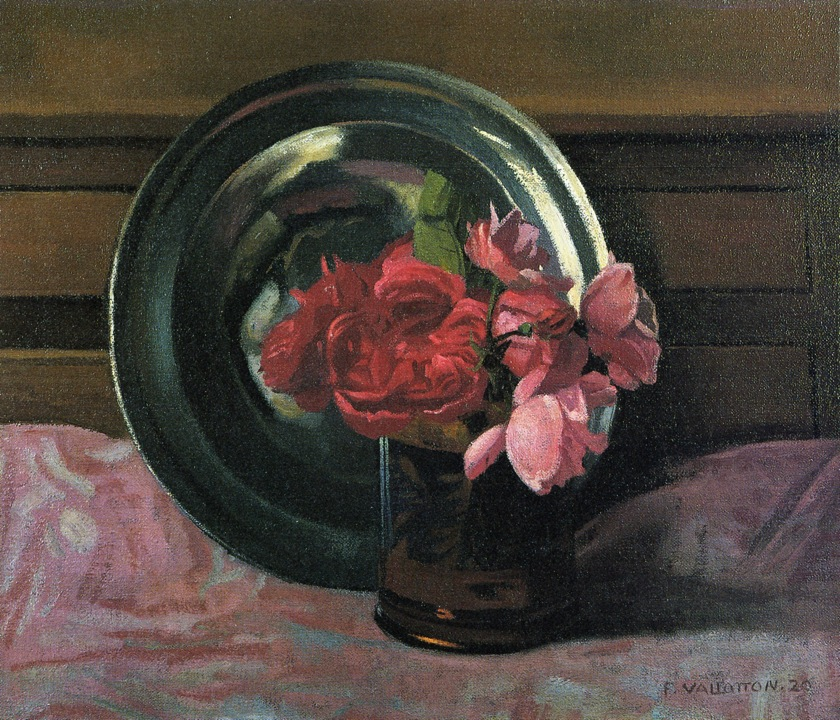Imagine this painting as part of a larger narrative. What scene or story could this still-life be a part of? In a grand Victorian mansion, this still-life painting could be found hanging in an elegantly furnished drawing room. The room is filled with antique furniture and rich tapestries, and the air is scented with the faint aroma of roses from a nearby garden. The painting itself holds deep sentimental value, perhaps a memento of a bygone era when the lady of the house, a passionate gardener, spent her afternoons tending to her beloved roses. Each bloom in the painting represents a memory, a story, or an emotion connected to significant moments in her life. This narrative weaves a tapestry of love, loss, and beauty, turning the painting into a cherished heirloom passed down through generations, each petal a silent witness to the family's history. If these roses could speak, what secrets would they reveal? If the roses in this painting could speak, they might reveal whispers of long-forgotten secrets and stories of the past. They could tell tales of heartfelt conversations held in the quiet elegance of the room where they were once displayed, of love letters written and read by candlelight, and of moments of solitary reflection. Each petal might share a different story—from quiet evenings spent in contemplation to grand celebrations where the room was filled with laughter and joy. They could speak of the artist’s meticulous care in capturing their essence on canvas, sharing insights into the struggles and triumphs that led to the final creation of this timeless piece. The roses, timeless witnesses to countless moments, would narrate a rich tapestry of human emotions, connecting the past with the present in a poetic dialogue. 